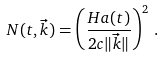<formula> <loc_0><loc_0><loc_500><loc_500>N ( t , \vec { k } ) = \left ( \frac { H a ( t ) } { 2 c \| \vec { k } \| } \right ) ^ { 2 } \, .</formula> 